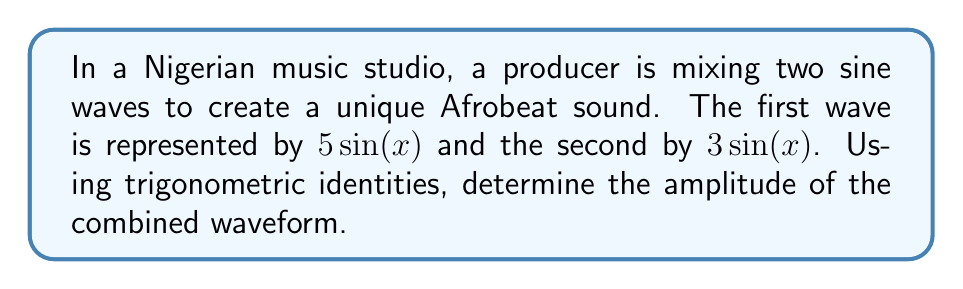Give your solution to this math problem. To solve this problem, we'll follow these steps:

1) The combined waveform is represented by the sum of the two sine waves:
   $5\sin(x) + 3\sin(x)$

2) We can factor out $\sin(x)$:
   $(5 + 3)\sin(x) = 8\sin(x)$

3) The general form of a sine wave is $A\sin(x)$, where $A$ is the amplitude.

4) In this case, we have $8\sin(x)$, so the amplitude is 8.

5) We can also derive this using the trigonometric identity for the sum of sines with equal angles:

   $a\sin(x) + b\sin(x) = (a + b)\sin(x)$

   Where $a = 5$ and $b = 3$ in our case.

6) The amplitude of this combined wave is $|a + b| = |5 + 3| = 8$

Therefore, the amplitude of the combined waveform is 8.
Answer: The amplitude of the combined waveform is 8. 